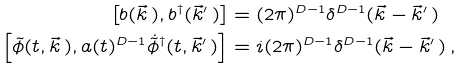Convert formula to latex. <formula><loc_0><loc_0><loc_500><loc_500>\left [ b ( \vec { k } \, ) , b ^ { \dagger } ( \vec { k } ^ { \prime } \, ) \right ] & = ( 2 \pi ) ^ { D - 1 } \delta ^ { D - 1 } ( \vec { k } - \vec { k } ^ { \prime } \, ) \\ \left [ \tilde { \phi } ( t , \vec { k } \, ) , a ( t ) ^ { D - 1 } \dot { \tilde { \phi } } ^ { \dagger } ( t , \vec { k } ^ { \prime } \, ) \right ] & = i ( 2 \pi ) ^ { D - 1 } \delta ^ { D - 1 } ( \vec { k } - \vec { k } ^ { \prime } \, ) \, ,</formula> 